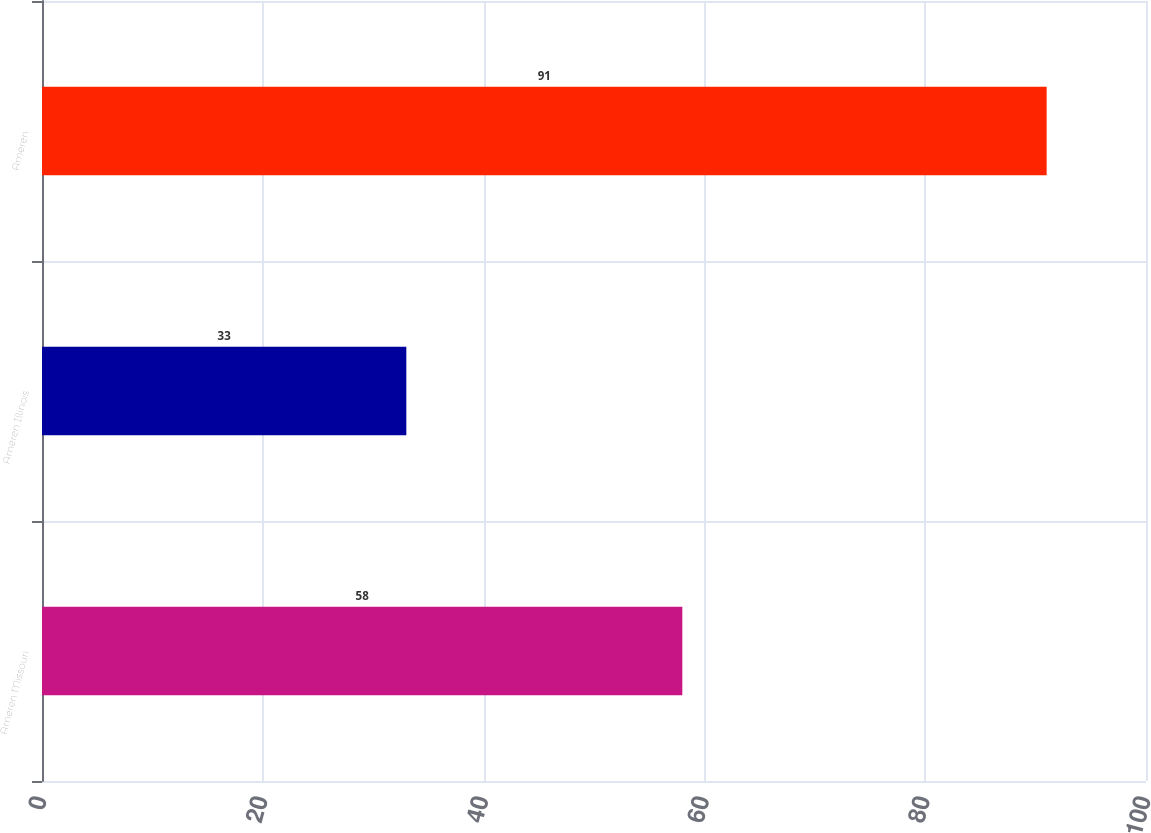<chart> <loc_0><loc_0><loc_500><loc_500><bar_chart><fcel>Ameren Missouri<fcel>Ameren Illinois<fcel>Ameren<nl><fcel>58<fcel>33<fcel>91<nl></chart> 